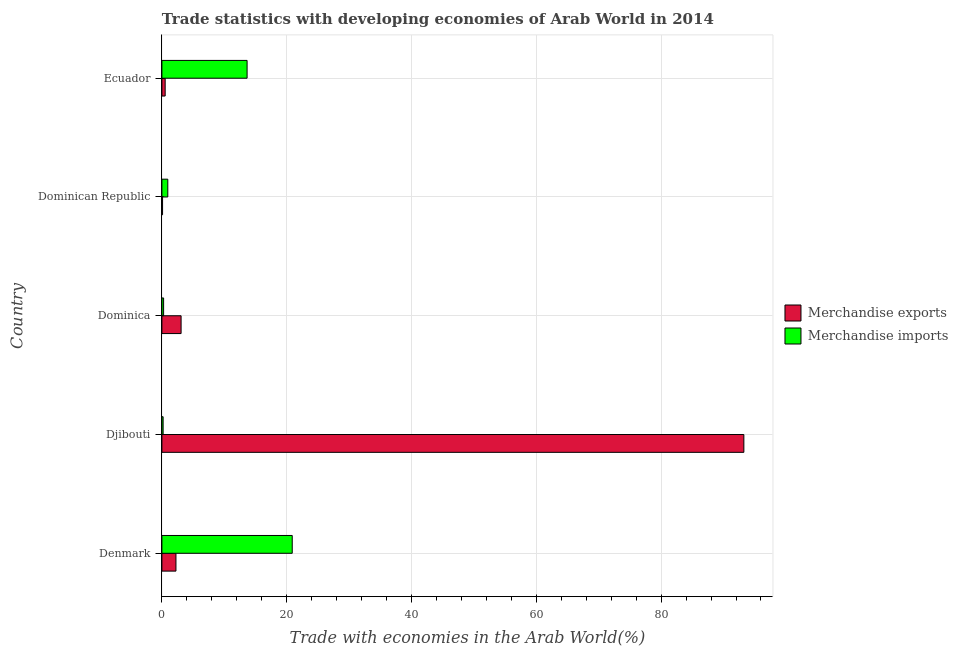Are the number of bars per tick equal to the number of legend labels?
Your response must be concise. Yes. Are the number of bars on each tick of the Y-axis equal?
Provide a short and direct response. Yes. What is the label of the 4th group of bars from the top?
Provide a short and direct response. Djibouti. In how many cases, is the number of bars for a given country not equal to the number of legend labels?
Offer a terse response. 0. What is the merchandise exports in Dominican Republic?
Provide a short and direct response. 0.1. Across all countries, what is the maximum merchandise imports?
Your answer should be compact. 20.89. Across all countries, what is the minimum merchandise imports?
Offer a very short reply. 0.2. In which country was the merchandise exports maximum?
Give a very brief answer. Djibouti. In which country was the merchandise imports minimum?
Your answer should be compact. Djibouti. What is the total merchandise exports in the graph?
Provide a succinct answer. 99.21. What is the difference between the merchandise imports in Djibouti and that in Ecuador?
Give a very brief answer. -13.46. What is the difference between the merchandise exports in Ecuador and the merchandise imports in Dominica?
Provide a short and direct response. 0.25. What is the average merchandise exports per country?
Provide a short and direct response. 19.84. What is the difference between the merchandise exports and merchandise imports in Dominica?
Your answer should be compact. 2.8. In how many countries, is the merchandise exports greater than 4 %?
Offer a very short reply. 1. What is the ratio of the merchandise exports in Dominica to that in Dominican Republic?
Offer a very short reply. 29.32. Is the difference between the merchandise exports in Denmark and Djibouti greater than the difference between the merchandise imports in Denmark and Djibouti?
Give a very brief answer. No. What is the difference between the highest and the second highest merchandise imports?
Your answer should be very brief. 7.23. What is the difference between the highest and the lowest merchandise exports?
Keep it short and to the point. 93.15. What does the 2nd bar from the bottom in Denmark represents?
Provide a succinct answer. Merchandise imports. What is the difference between two consecutive major ticks on the X-axis?
Your answer should be compact. 20. Does the graph contain any zero values?
Ensure brevity in your answer.  No. Does the graph contain grids?
Offer a terse response. Yes. What is the title of the graph?
Provide a succinct answer. Trade statistics with developing economies of Arab World in 2014. What is the label or title of the X-axis?
Ensure brevity in your answer.  Trade with economies in the Arab World(%). What is the Trade with economies in the Arab World(%) in Merchandise exports in Denmark?
Provide a short and direct response. 2.25. What is the Trade with economies in the Arab World(%) of Merchandise imports in Denmark?
Keep it short and to the point. 20.89. What is the Trade with economies in the Arab World(%) in Merchandise exports in Djibouti?
Your answer should be very brief. 93.26. What is the Trade with economies in the Arab World(%) in Merchandise imports in Djibouti?
Give a very brief answer. 0.2. What is the Trade with economies in the Arab World(%) in Merchandise exports in Dominica?
Give a very brief answer. 3.07. What is the Trade with economies in the Arab World(%) of Merchandise imports in Dominica?
Ensure brevity in your answer.  0.27. What is the Trade with economies in the Arab World(%) in Merchandise exports in Dominican Republic?
Keep it short and to the point. 0.1. What is the Trade with economies in the Arab World(%) in Merchandise imports in Dominican Republic?
Provide a short and direct response. 0.94. What is the Trade with economies in the Arab World(%) of Merchandise exports in Ecuador?
Offer a very short reply. 0.52. What is the Trade with economies in the Arab World(%) in Merchandise imports in Ecuador?
Make the answer very short. 13.65. Across all countries, what is the maximum Trade with economies in the Arab World(%) in Merchandise exports?
Keep it short and to the point. 93.26. Across all countries, what is the maximum Trade with economies in the Arab World(%) of Merchandise imports?
Offer a terse response. 20.89. Across all countries, what is the minimum Trade with economies in the Arab World(%) in Merchandise exports?
Ensure brevity in your answer.  0.1. Across all countries, what is the minimum Trade with economies in the Arab World(%) of Merchandise imports?
Provide a short and direct response. 0.2. What is the total Trade with economies in the Arab World(%) in Merchandise exports in the graph?
Give a very brief answer. 99.21. What is the total Trade with economies in the Arab World(%) in Merchandise imports in the graph?
Keep it short and to the point. 35.95. What is the difference between the Trade with economies in the Arab World(%) in Merchandise exports in Denmark and that in Djibouti?
Keep it short and to the point. -91.01. What is the difference between the Trade with economies in the Arab World(%) in Merchandise imports in Denmark and that in Djibouti?
Ensure brevity in your answer.  20.69. What is the difference between the Trade with economies in the Arab World(%) in Merchandise exports in Denmark and that in Dominica?
Offer a terse response. -0.82. What is the difference between the Trade with economies in the Arab World(%) of Merchandise imports in Denmark and that in Dominica?
Your response must be concise. 20.61. What is the difference between the Trade with economies in the Arab World(%) of Merchandise exports in Denmark and that in Dominican Republic?
Provide a succinct answer. 2.15. What is the difference between the Trade with economies in the Arab World(%) in Merchandise imports in Denmark and that in Dominican Republic?
Ensure brevity in your answer.  19.94. What is the difference between the Trade with economies in the Arab World(%) in Merchandise exports in Denmark and that in Ecuador?
Keep it short and to the point. 1.73. What is the difference between the Trade with economies in the Arab World(%) in Merchandise imports in Denmark and that in Ecuador?
Your answer should be very brief. 7.23. What is the difference between the Trade with economies in the Arab World(%) of Merchandise exports in Djibouti and that in Dominica?
Make the answer very short. 90.18. What is the difference between the Trade with economies in the Arab World(%) in Merchandise imports in Djibouti and that in Dominica?
Offer a very short reply. -0.08. What is the difference between the Trade with economies in the Arab World(%) in Merchandise exports in Djibouti and that in Dominican Republic?
Provide a succinct answer. 93.15. What is the difference between the Trade with economies in the Arab World(%) in Merchandise imports in Djibouti and that in Dominican Republic?
Your answer should be compact. -0.75. What is the difference between the Trade with economies in the Arab World(%) of Merchandise exports in Djibouti and that in Ecuador?
Your answer should be very brief. 92.73. What is the difference between the Trade with economies in the Arab World(%) of Merchandise imports in Djibouti and that in Ecuador?
Provide a short and direct response. -13.46. What is the difference between the Trade with economies in the Arab World(%) in Merchandise exports in Dominica and that in Dominican Republic?
Provide a succinct answer. 2.97. What is the difference between the Trade with economies in the Arab World(%) of Merchandise imports in Dominica and that in Dominican Republic?
Your answer should be very brief. -0.67. What is the difference between the Trade with economies in the Arab World(%) in Merchandise exports in Dominica and that in Ecuador?
Give a very brief answer. 2.55. What is the difference between the Trade with economies in the Arab World(%) of Merchandise imports in Dominica and that in Ecuador?
Offer a terse response. -13.38. What is the difference between the Trade with economies in the Arab World(%) of Merchandise exports in Dominican Republic and that in Ecuador?
Give a very brief answer. -0.42. What is the difference between the Trade with economies in the Arab World(%) in Merchandise imports in Dominican Republic and that in Ecuador?
Offer a very short reply. -12.71. What is the difference between the Trade with economies in the Arab World(%) of Merchandise exports in Denmark and the Trade with economies in the Arab World(%) of Merchandise imports in Djibouti?
Offer a terse response. 2.05. What is the difference between the Trade with economies in the Arab World(%) in Merchandise exports in Denmark and the Trade with economies in the Arab World(%) in Merchandise imports in Dominica?
Offer a very short reply. 1.98. What is the difference between the Trade with economies in the Arab World(%) in Merchandise exports in Denmark and the Trade with economies in the Arab World(%) in Merchandise imports in Dominican Republic?
Offer a terse response. 1.31. What is the difference between the Trade with economies in the Arab World(%) of Merchandise exports in Denmark and the Trade with economies in the Arab World(%) of Merchandise imports in Ecuador?
Give a very brief answer. -11.4. What is the difference between the Trade with economies in the Arab World(%) of Merchandise exports in Djibouti and the Trade with economies in the Arab World(%) of Merchandise imports in Dominica?
Provide a succinct answer. 92.98. What is the difference between the Trade with economies in the Arab World(%) of Merchandise exports in Djibouti and the Trade with economies in the Arab World(%) of Merchandise imports in Dominican Republic?
Keep it short and to the point. 92.31. What is the difference between the Trade with economies in the Arab World(%) in Merchandise exports in Djibouti and the Trade with economies in the Arab World(%) in Merchandise imports in Ecuador?
Offer a very short reply. 79.61. What is the difference between the Trade with economies in the Arab World(%) in Merchandise exports in Dominica and the Trade with economies in the Arab World(%) in Merchandise imports in Dominican Republic?
Your response must be concise. 2.13. What is the difference between the Trade with economies in the Arab World(%) of Merchandise exports in Dominica and the Trade with economies in the Arab World(%) of Merchandise imports in Ecuador?
Your answer should be very brief. -10.58. What is the difference between the Trade with economies in the Arab World(%) of Merchandise exports in Dominican Republic and the Trade with economies in the Arab World(%) of Merchandise imports in Ecuador?
Provide a succinct answer. -13.55. What is the average Trade with economies in the Arab World(%) of Merchandise exports per country?
Your response must be concise. 19.84. What is the average Trade with economies in the Arab World(%) of Merchandise imports per country?
Ensure brevity in your answer.  7.19. What is the difference between the Trade with economies in the Arab World(%) of Merchandise exports and Trade with economies in the Arab World(%) of Merchandise imports in Denmark?
Provide a succinct answer. -18.63. What is the difference between the Trade with economies in the Arab World(%) in Merchandise exports and Trade with economies in the Arab World(%) in Merchandise imports in Djibouti?
Offer a very short reply. 93.06. What is the difference between the Trade with economies in the Arab World(%) of Merchandise exports and Trade with economies in the Arab World(%) of Merchandise imports in Dominica?
Your answer should be compact. 2.8. What is the difference between the Trade with economies in the Arab World(%) of Merchandise exports and Trade with economies in the Arab World(%) of Merchandise imports in Dominican Republic?
Keep it short and to the point. -0.84. What is the difference between the Trade with economies in the Arab World(%) of Merchandise exports and Trade with economies in the Arab World(%) of Merchandise imports in Ecuador?
Your response must be concise. -13.13. What is the ratio of the Trade with economies in the Arab World(%) in Merchandise exports in Denmark to that in Djibouti?
Your answer should be very brief. 0.02. What is the ratio of the Trade with economies in the Arab World(%) of Merchandise imports in Denmark to that in Djibouti?
Provide a short and direct response. 106.45. What is the ratio of the Trade with economies in the Arab World(%) of Merchandise exports in Denmark to that in Dominica?
Provide a short and direct response. 0.73. What is the ratio of the Trade with economies in the Arab World(%) in Merchandise imports in Denmark to that in Dominica?
Offer a terse response. 76.08. What is the ratio of the Trade with economies in the Arab World(%) in Merchandise exports in Denmark to that in Dominican Republic?
Give a very brief answer. 21.46. What is the ratio of the Trade with economies in the Arab World(%) of Merchandise imports in Denmark to that in Dominican Republic?
Your answer should be very brief. 22.12. What is the ratio of the Trade with economies in the Arab World(%) in Merchandise exports in Denmark to that in Ecuador?
Give a very brief answer. 4.3. What is the ratio of the Trade with economies in the Arab World(%) of Merchandise imports in Denmark to that in Ecuador?
Make the answer very short. 1.53. What is the ratio of the Trade with economies in the Arab World(%) in Merchandise exports in Djibouti to that in Dominica?
Keep it short and to the point. 30.33. What is the ratio of the Trade with economies in the Arab World(%) in Merchandise imports in Djibouti to that in Dominica?
Give a very brief answer. 0.71. What is the ratio of the Trade with economies in the Arab World(%) of Merchandise exports in Djibouti to that in Dominican Republic?
Provide a succinct answer. 889.25. What is the ratio of the Trade with economies in the Arab World(%) of Merchandise imports in Djibouti to that in Dominican Republic?
Provide a succinct answer. 0.21. What is the ratio of the Trade with economies in the Arab World(%) of Merchandise exports in Djibouti to that in Ecuador?
Your answer should be compact. 178.07. What is the ratio of the Trade with economies in the Arab World(%) of Merchandise imports in Djibouti to that in Ecuador?
Offer a terse response. 0.01. What is the ratio of the Trade with economies in the Arab World(%) in Merchandise exports in Dominica to that in Dominican Republic?
Provide a succinct answer. 29.32. What is the ratio of the Trade with economies in the Arab World(%) in Merchandise imports in Dominica to that in Dominican Republic?
Offer a terse response. 0.29. What is the ratio of the Trade with economies in the Arab World(%) of Merchandise exports in Dominica to that in Ecuador?
Your answer should be very brief. 5.87. What is the ratio of the Trade with economies in the Arab World(%) of Merchandise imports in Dominica to that in Ecuador?
Give a very brief answer. 0.02. What is the ratio of the Trade with economies in the Arab World(%) of Merchandise exports in Dominican Republic to that in Ecuador?
Offer a terse response. 0.2. What is the ratio of the Trade with economies in the Arab World(%) in Merchandise imports in Dominican Republic to that in Ecuador?
Make the answer very short. 0.07. What is the difference between the highest and the second highest Trade with economies in the Arab World(%) of Merchandise exports?
Offer a terse response. 90.18. What is the difference between the highest and the second highest Trade with economies in the Arab World(%) in Merchandise imports?
Make the answer very short. 7.23. What is the difference between the highest and the lowest Trade with economies in the Arab World(%) in Merchandise exports?
Your answer should be compact. 93.15. What is the difference between the highest and the lowest Trade with economies in the Arab World(%) in Merchandise imports?
Offer a very short reply. 20.69. 